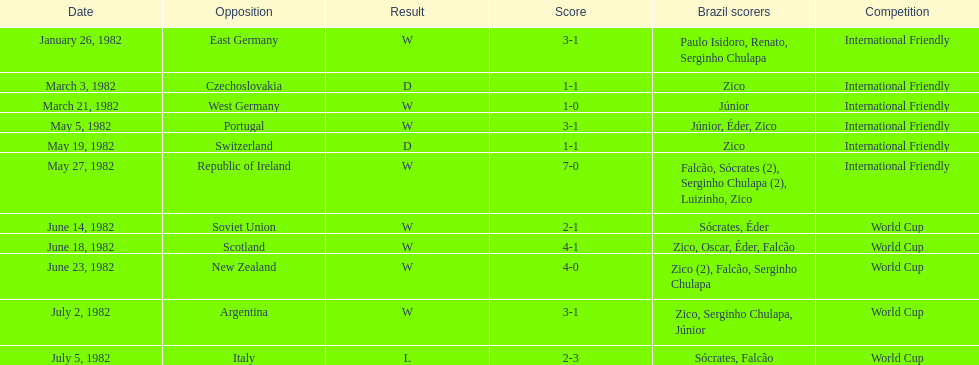On january 26, 1982, and may 27, 1982, who claimed victory? Brazil. 